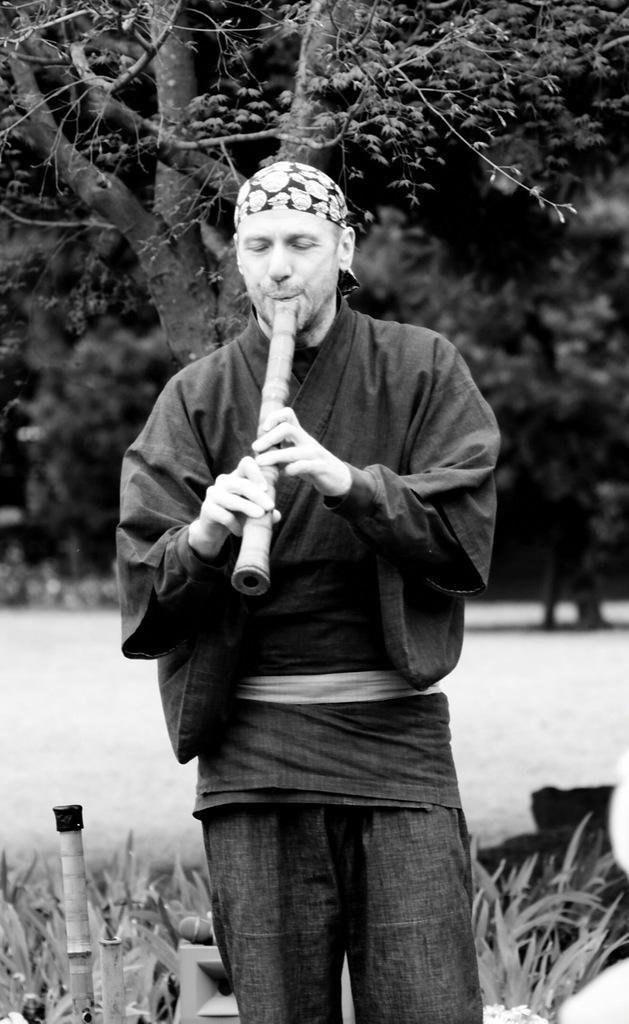Can you describe this image briefly? Here we can see a man playing a musical instrument and behind him there are trees and plants 